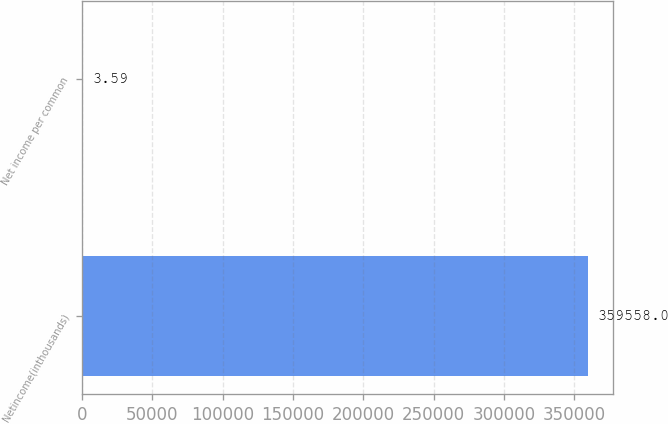Convert chart to OTSL. <chart><loc_0><loc_0><loc_500><loc_500><bar_chart><fcel>Netincome(inthousands)<fcel>Net income per common<nl><fcel>359558<fcel>3.59<nl></chart> 